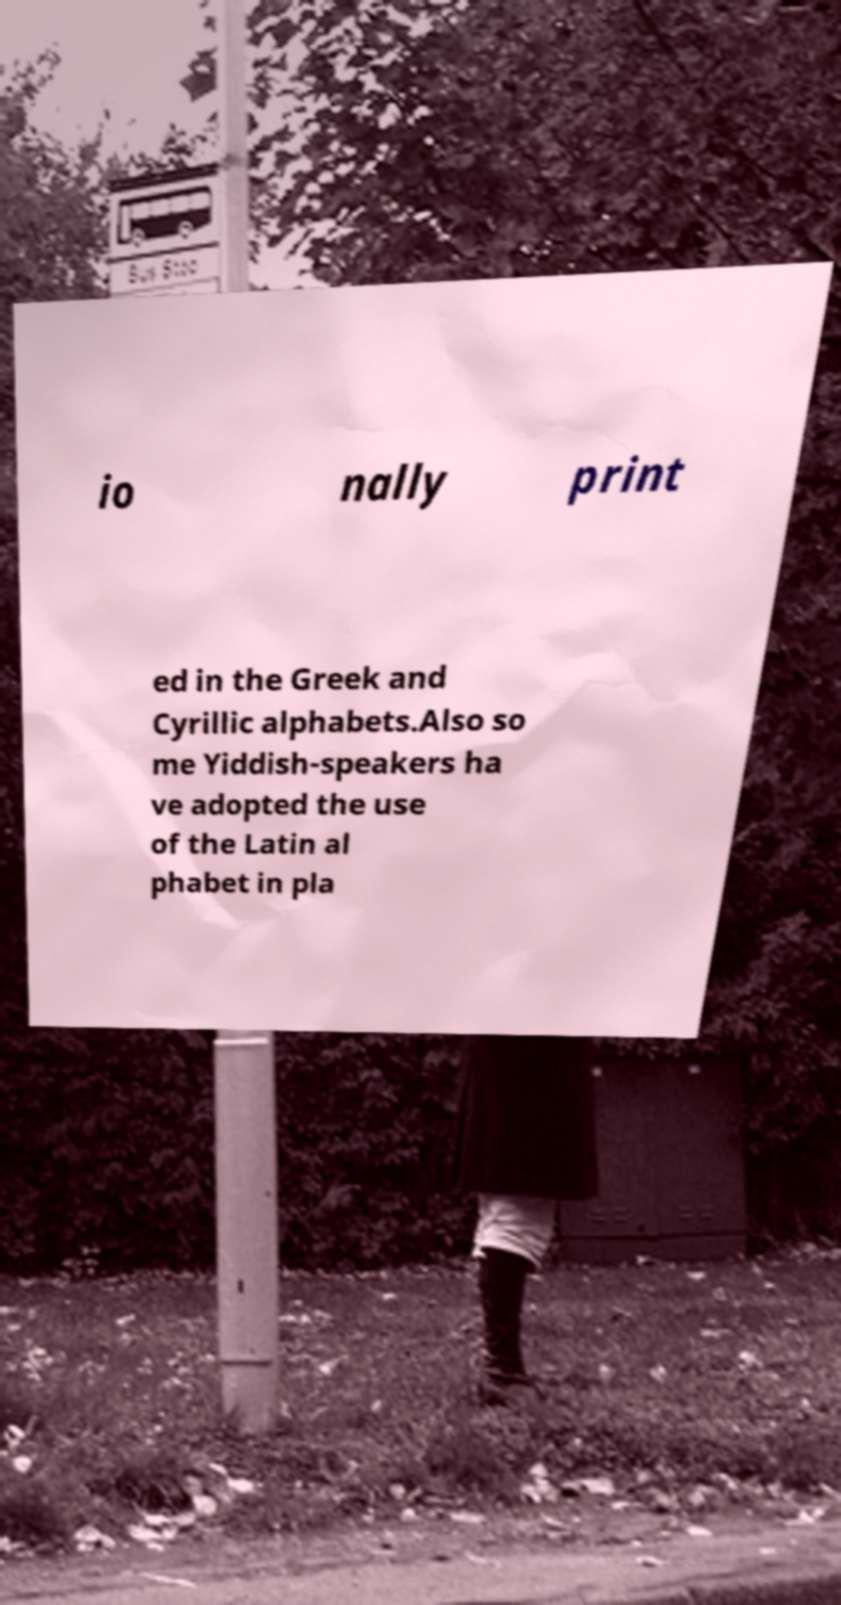For documentation purposes, I need the text within this image transcribed. Could you provide that? io nally print ed in the Greek and Cyrillic alphabets.Also so me Yiddish-speakers ha ve adopted the use of the Latin al phabet in pla 